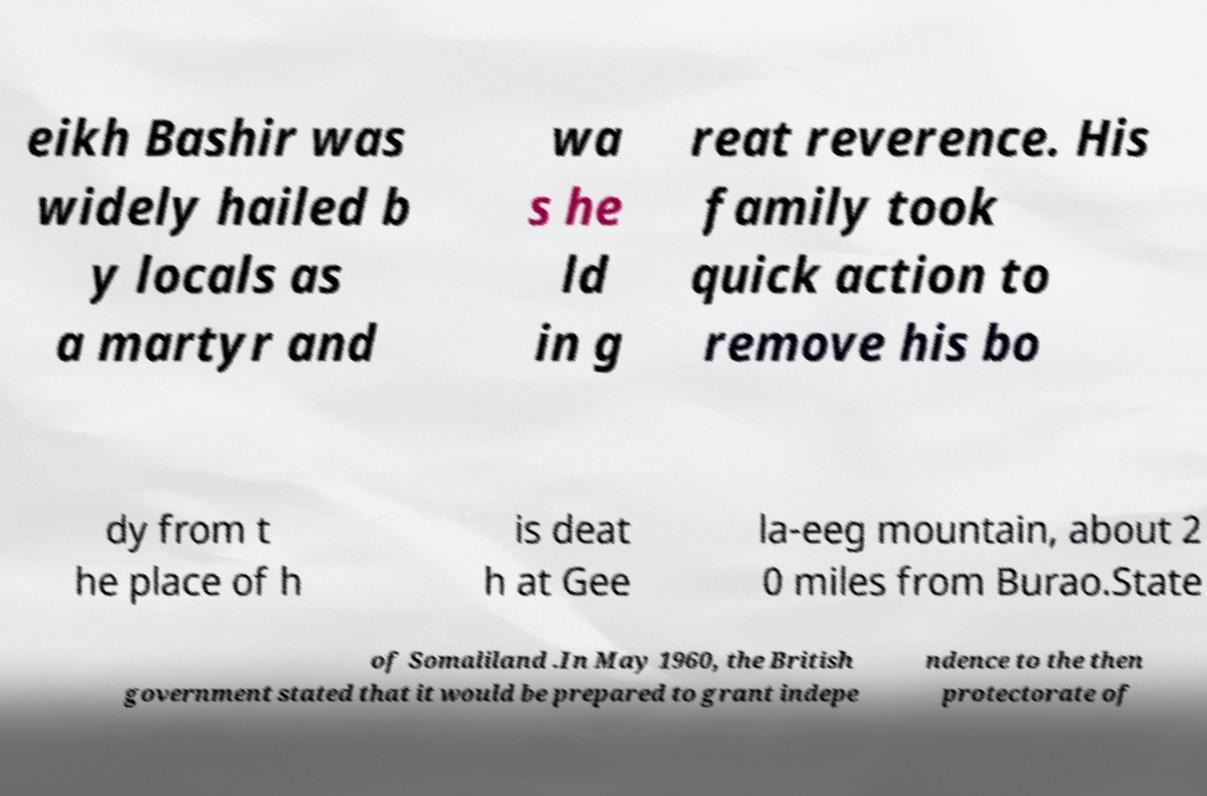Please read and relay the text visible in this image. What does it say? eikh Bashir was widely hailed b y locals as a martyr and wa s he ld in g reat reverence. His family took quick action to remove his bo dy from t he place of h is deat h at Gee la-eeg mountain, about 2 0 miles from Burao.State of Somaliland .In May 1960, the British government stated that it would be prepared to grant indepe ndence to the then protectorate of 